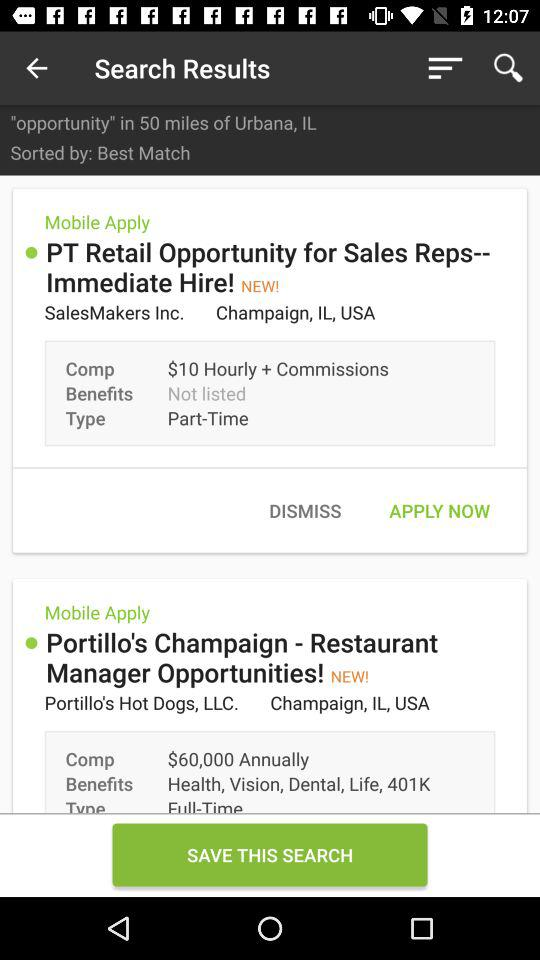Within what distance is the opportunity shown? The shown opportunity is within 50 miles. 